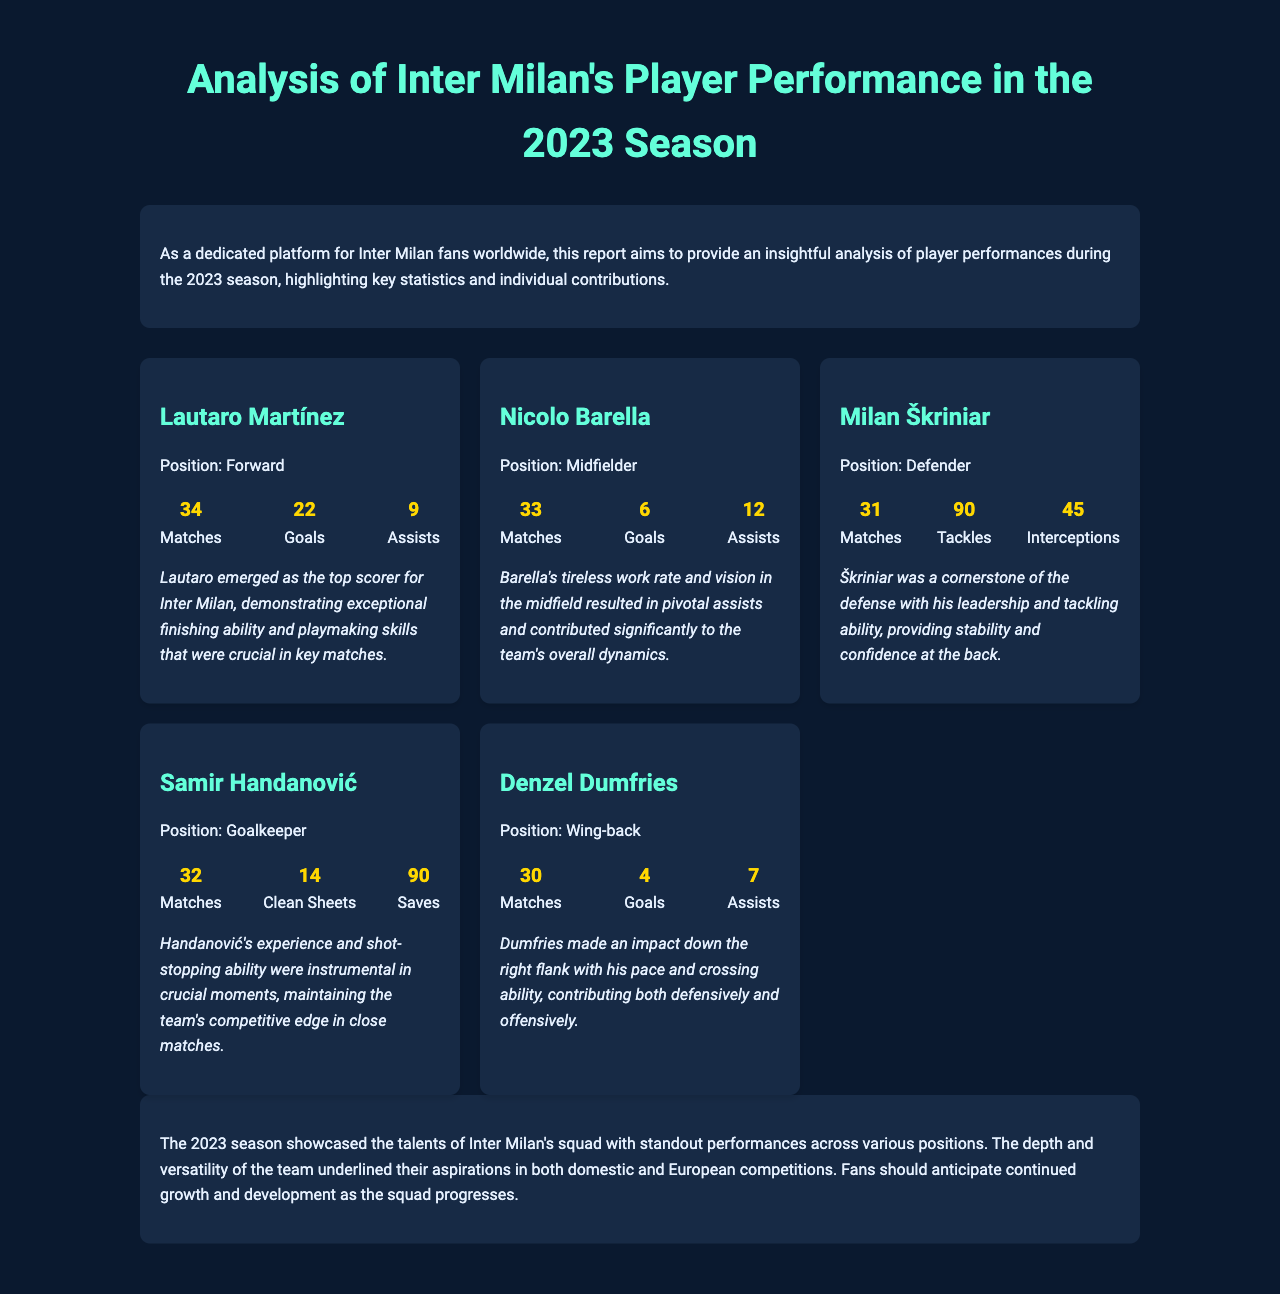What is Lautaro Martínez's position? Lautaro Martínez is identified as a Forward in the document.
Answer: Forward How many goals did Nicolo Barella score? The document states that Nicolo Barella scored 6 goals during the season.
Answer: 6 What was Milan Škriniar's total number of tackles? Milan Škriniar had a total of 90 tackles as highlighted in the statistics.
Answer: 90 How many clean sheets did Samir Handanović achieve? According to the document, Samir Handanović achieved 14 clean sheets.
Answer: 14 Which player had the highest number of assists? The player with the highest number of assists is Nicolo Barella with 12 assists.
Answer: Nicolo Barella What key skill did Lautaro Martínez demonstrate? The report mentions that Lautaro demonstrated exceptional finishing ability and playmaking skills.
Answer: Finishing ability and playmaking skills How many matches did Denzel Dumfries play? Denzel Dumfries is reported to have played 30 matches during the season.
Answer: 30 What is the main focus of this report? The report primarily focuses on analyzing player performances during the 2023 season for Inter Milan.
Answer: Analyzing player performances What was a significant highlight of the 2023 season for Inter Milan? The season showcased standout performances across various positions in the squad.
Answer: Standout performances across various positions 